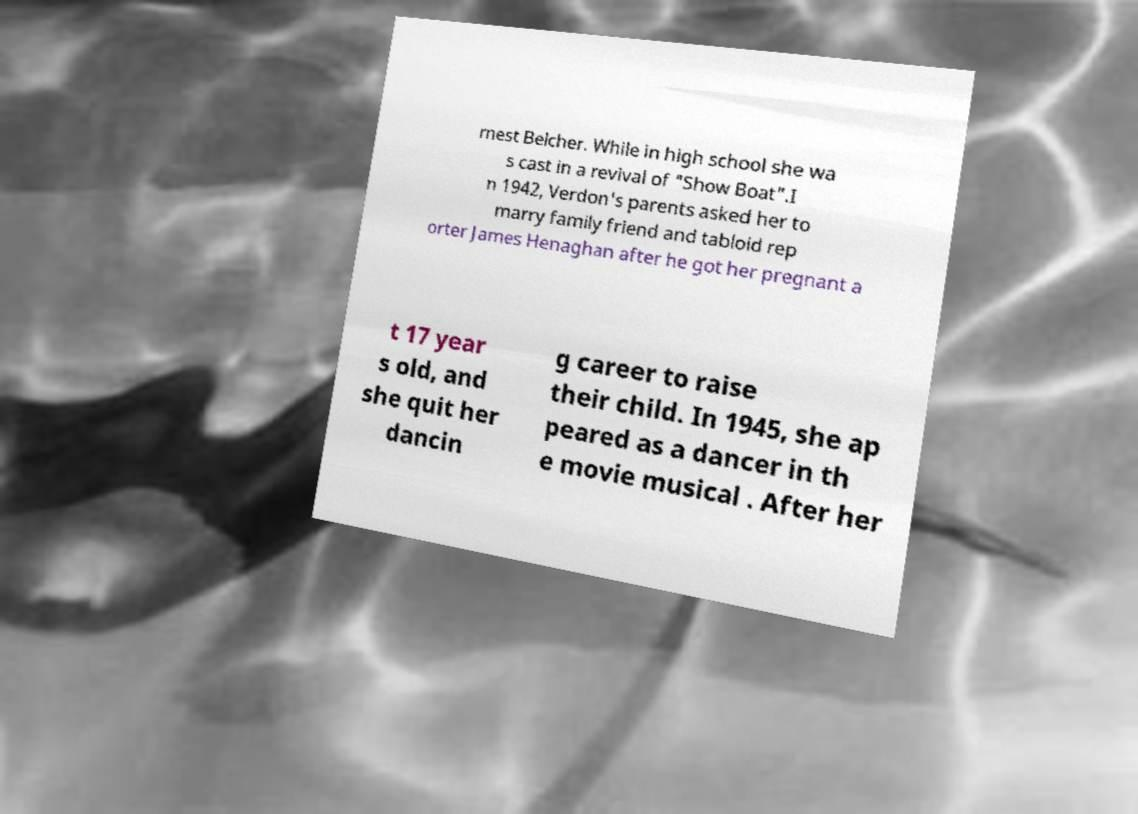What messages or text are displayed in this image? I need them in a readable, typed format. rnest Belcher. While in high school she wa s cast in a revival of "Show Boat".I n 1942, Verdon's parents asked her to marry family friend and tabloid rep orter James Henaghan after he got her pregnant a t 17 year s old, and she quit her dancin g career to raise their child. In 1945, she ap peared as a dancer in th e movie musical . After her 